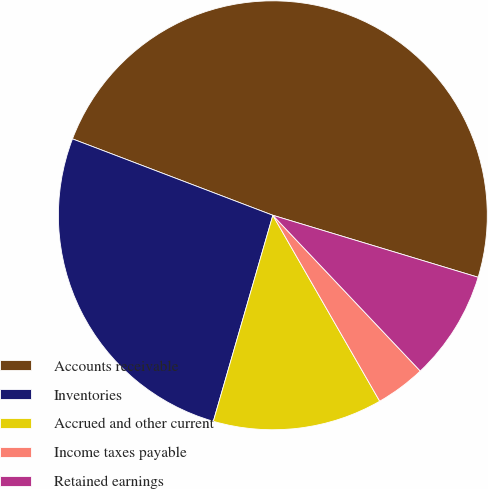Convert chart. <chart><loc_0><loc_0><loc_500><loc_500><pie_chart><fcel>Accounts receivable<fcel>Inventories<fcel>Accrued and other current<fcel>Income taxes payable<fcel>Retained earnings<nl><fcel>48.87%<fcel>26.32%<fcel>12.78%<fcel>3.76%<fcel>8.27%<nl></chart> 